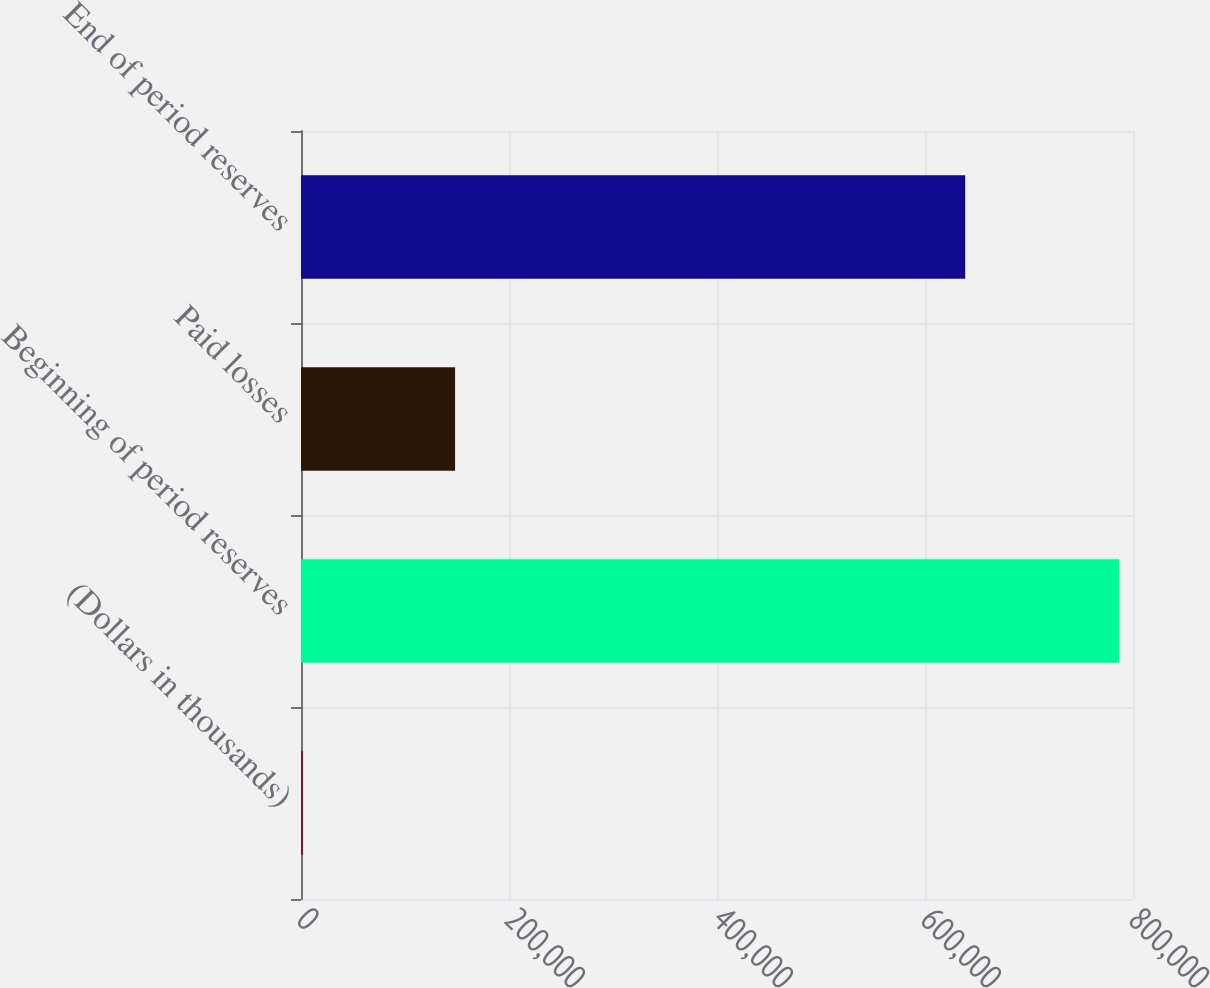Convert chart. <chart><loc_0><loc_0><loc_500><loc_500><bar_chart><fcel>(Dollars in thousands)<fcel>Beginning of period reserves<fcel>Paid losses<fcel>End of period reserves<nl><fcel>2009<fcel>786843<fcel>148169<fcel>638674<nl></chart> 